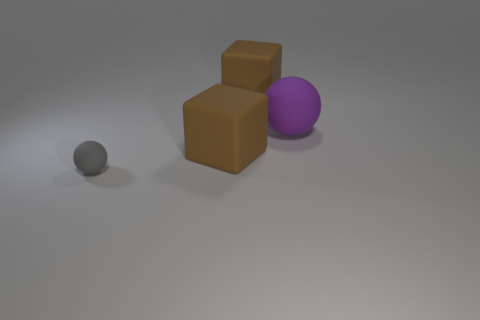Add 3 rubber things. How many objects exist? 7 Add 2 large purple rubber objects. How many large purple rubber objects exist? 3 Subtract 1 purple balls. How many objects are left? 3 Subtract all large cyan metal blocks. Subtract all blocks. How many objects are left? 2 Add 2 tiny gray objects. How many tiny gray objects are left? 3 